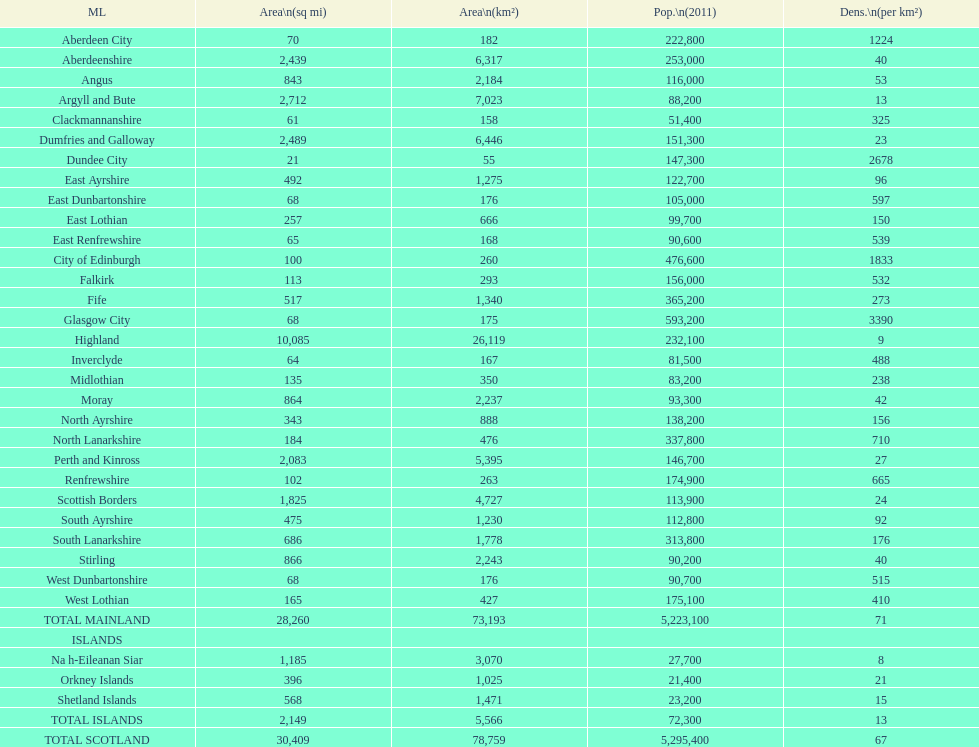What number of mainlands have populations under 100,000? 9. 